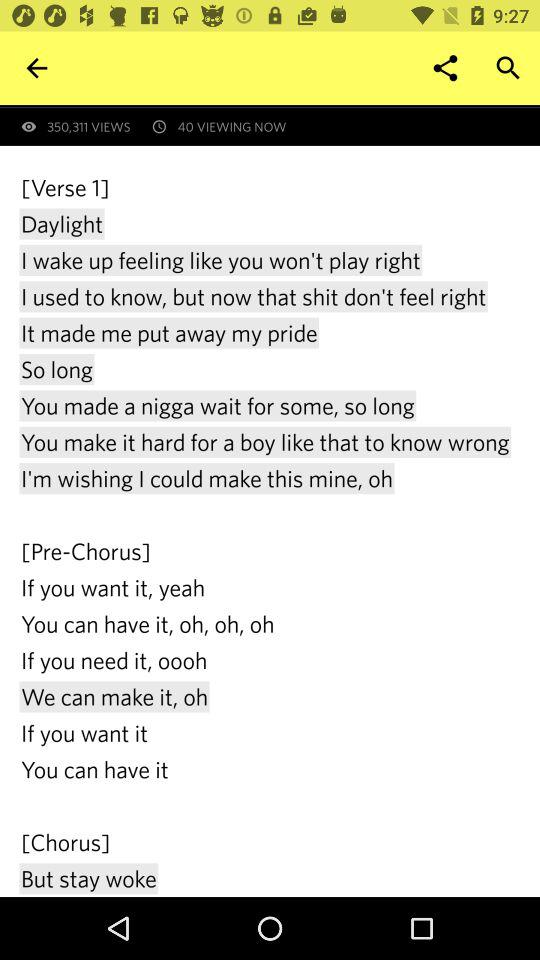How many people viewed it? The people who viewed it are 350,311. 